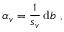<formula> <loc_0><loc_0><loc_500><loc_500>\alpha _ { v } = \frac { 1 } { s _ { v } } \, d b \ ,</formula> 